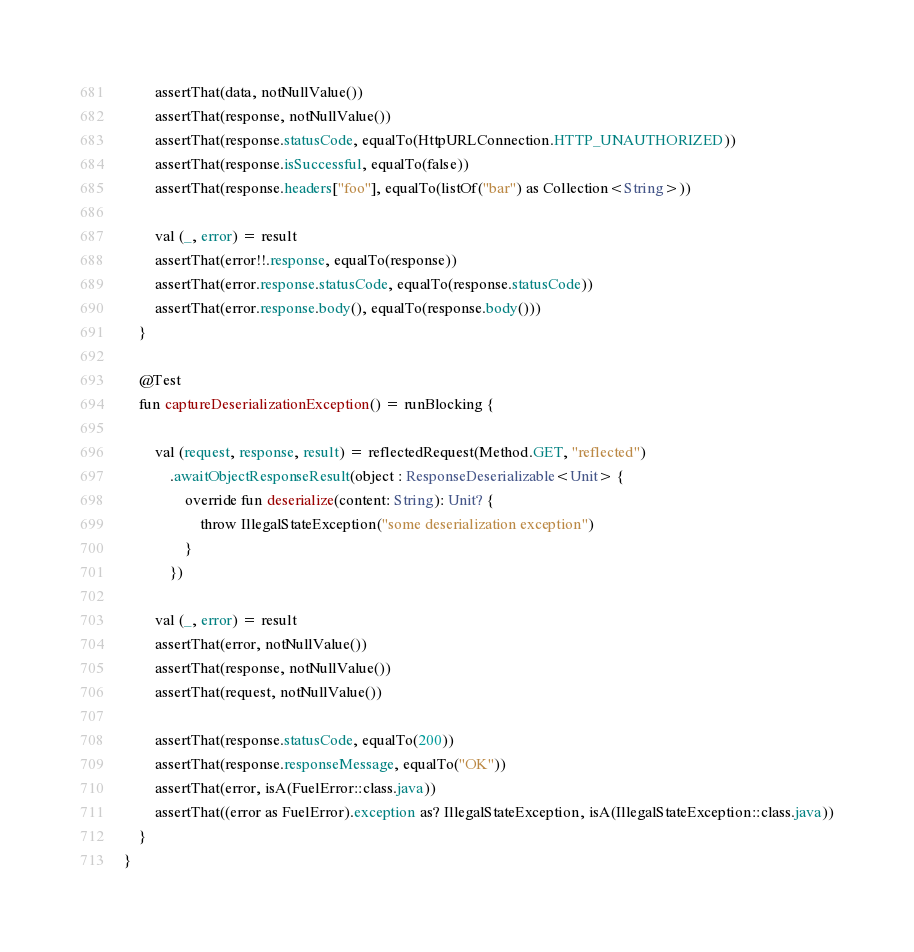<code> <loc_0><loc_0><loc_500><loc_500><_Kotlin_>        assertThat(data, notNullValue())
        assertThat(response, notNullValue())
        assertThat(response.statusCode, equalTo(HttpURLConnection.HTTP_UNAUTHORIZED))
        assertThat(response.isSuccessful, equalTo(false))
        assertThat(response.headers["foo"], equalTo(listOf("bar") as Collection<String>))

        val (_, error) = result
        assertThat(error!!.response, equalTo(response))
        assertThat(error.response.statusCode, equalTo(response.statusCode))
        assertThat(error.response.body(), equalTo(response.body()))
    }

    @Test
    fun captureDeserializationException() = runBlocking {

        val (request, response, result) = reflectedRequest(Method.GET, "reflected")
            .awaitObjectResponseResult(object : ResponseDeserializable<Unit> {
                override fun deserialize(content: String): Unit? {
                    throw IllegalStateException("some deserialization exception")
                }
            })

        val (_, error) = result
        assertThat(error, notNullValue())
        assertThat(response, notNullValue())
        assertThat(request, notNullValue())

        assertThat(response.statusCode, equalTo(200))
        assertThat(response.responseMessage, equalTo("OK"))
        assertThat(error, isA(FuelError::class.java))
        assertThat((error as FuelError).exception as? IllegalStateException, isA(IllegalStateException::class.java))
    }
}
</code> 